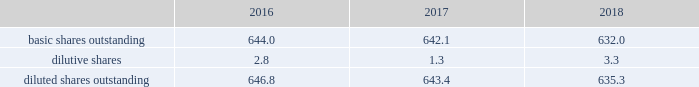2018 emerson annual report | 37 inco me taxes the provision for income taxes is based on pretax income reported in the consolidated statements of earnings and tax rates currently enacted in each jurisdiction .
Certain income and expense items are recognized in different time periods for financial reporting and income tax filing purposes , and deferred income taxes are provided for the effect of temporary differences .
The company also provides for foreign withholding taxes and any applicable u.s .
Income taxes on earnings intended to be repatriated from non-u.s .
Locations .
No provision has been made for these taxes on approximately $ 3.4 billion of undistributed earnings of non-u.s .
Subsidiaries as of september 30 , 2018 , as these earnings are considered indefinitely invested or otherwise retained for continuing international operations .
Recognition of foreign withholding taxes and any applicable u.s .
Income taxes on undistributed non-u.s .
Earnings would be triggered by a management decision to repatriate those earnings .
Determination of the amount of taxes that might be paid on these undistributed earnings if eventually remitted is not practicable .
See note 14 .
( 2 ) weighted-average common shares basic earnings per common share consider only the weighted-average of common shares outstanding while diluted earnings per common share also consider the dilutive effects of stock options and incentive shares .
An inconsequential number of shares of common stock were excluded from the computation of dilutive earnings per in 2018 as the effect would have been antidilutive , while 4.5 million and 13.3 million shares of common stock were excluded in 2017 and 2016 , respectively .
Earnings allocated to participating securities were inconsequential for all years presented .
Reconciliations of weighted-average shares for basic and diluted earnings per common share follow ( shares in millions ) : 2016 2017 2018 .
( 3 ) acquisitions and divestitures on july 17 , 2018 , the company completed the acquisition of aventics , a global provider of smart pneumatics technologies that power machine and factory automation applications , for $ 622 , net of cash acquired .
This business , which has annual sales of approximately $ 425 , is reported in the industrial solutions product offering in the automation solutions segment .
The company recognized goodwill of $ 358 ( $ 20 of which is expected to be tax deductible ) , and identifiable intangible assets of $ 278 , primarily intellectual property and customer relationships with a weighted-average useful life of approximately 12 years .
On july 2 , 2018 , the company completed the acquisition of textron 2019s tools and test equipment business for $ 810 , net of cash acquired .
This business , with annual sales of approximately $ 470 , is a manufacturer of electrical and utility tools , diagnostics , and test and measurement instruments , and is reported in the tools & home products segment .
The company recognized goodwill of $ 374 ( $ 17 of which is expected to be tax deductible ) , and identifiable intangible assets of $ 358 , primarily intellectual property and customer relationships with a weighted-average useful life of approximately 14 years .
On december 1 , 2017 , the company acquired paradigm , a provider of software solutions for the oil and gas industry , for $ 505 , net of cash acquired .
This business had annual sales of approximately $ 140 and is included in the measurement & analytical instrumentation product offering within automation solutions .
The company recognized goodwill of $ 328 ( $ 160 of which is expected to be tax deductible ) , and identifiable intangible assets of $ 238 , primarily intellectual property and customer relationships with a weighted-average useful life of approximately 11 years .
During 2018 , the company also acquired four smaller businesses , two in the automation solutions segment and two in the climate technologies segment. .
For the textron 2019s tools and test equipment business acquisition what was the ratio of price paid to annual sales? 
Rationale: this is a standard valuation measure and can point out if the price was in line .
Computations: (810 / 470)
Answer: 1.7234. 